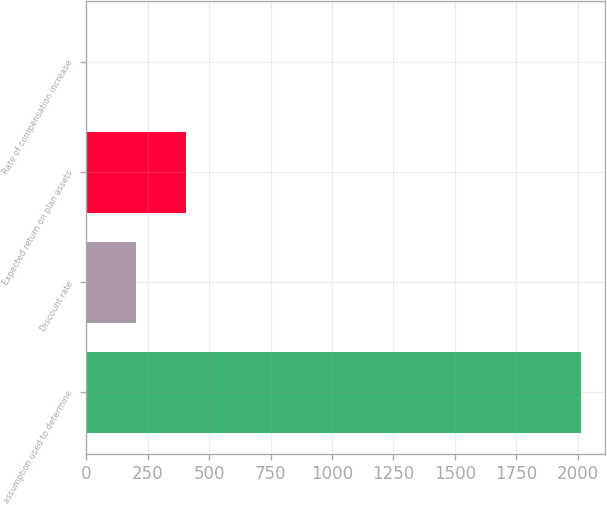Convert chart to OTSL. <chart><loc_0><loc_0><loc_500><loc_500><bar_chart><fcel>assumption used to determine<fcel>Discount rate<fcel>Expected return on plan assets<fcel>Rate of compensation increase<nl><fcel>2012<fcel>203.79<fcel>404.7<fcel>2.88<nl></chart> 